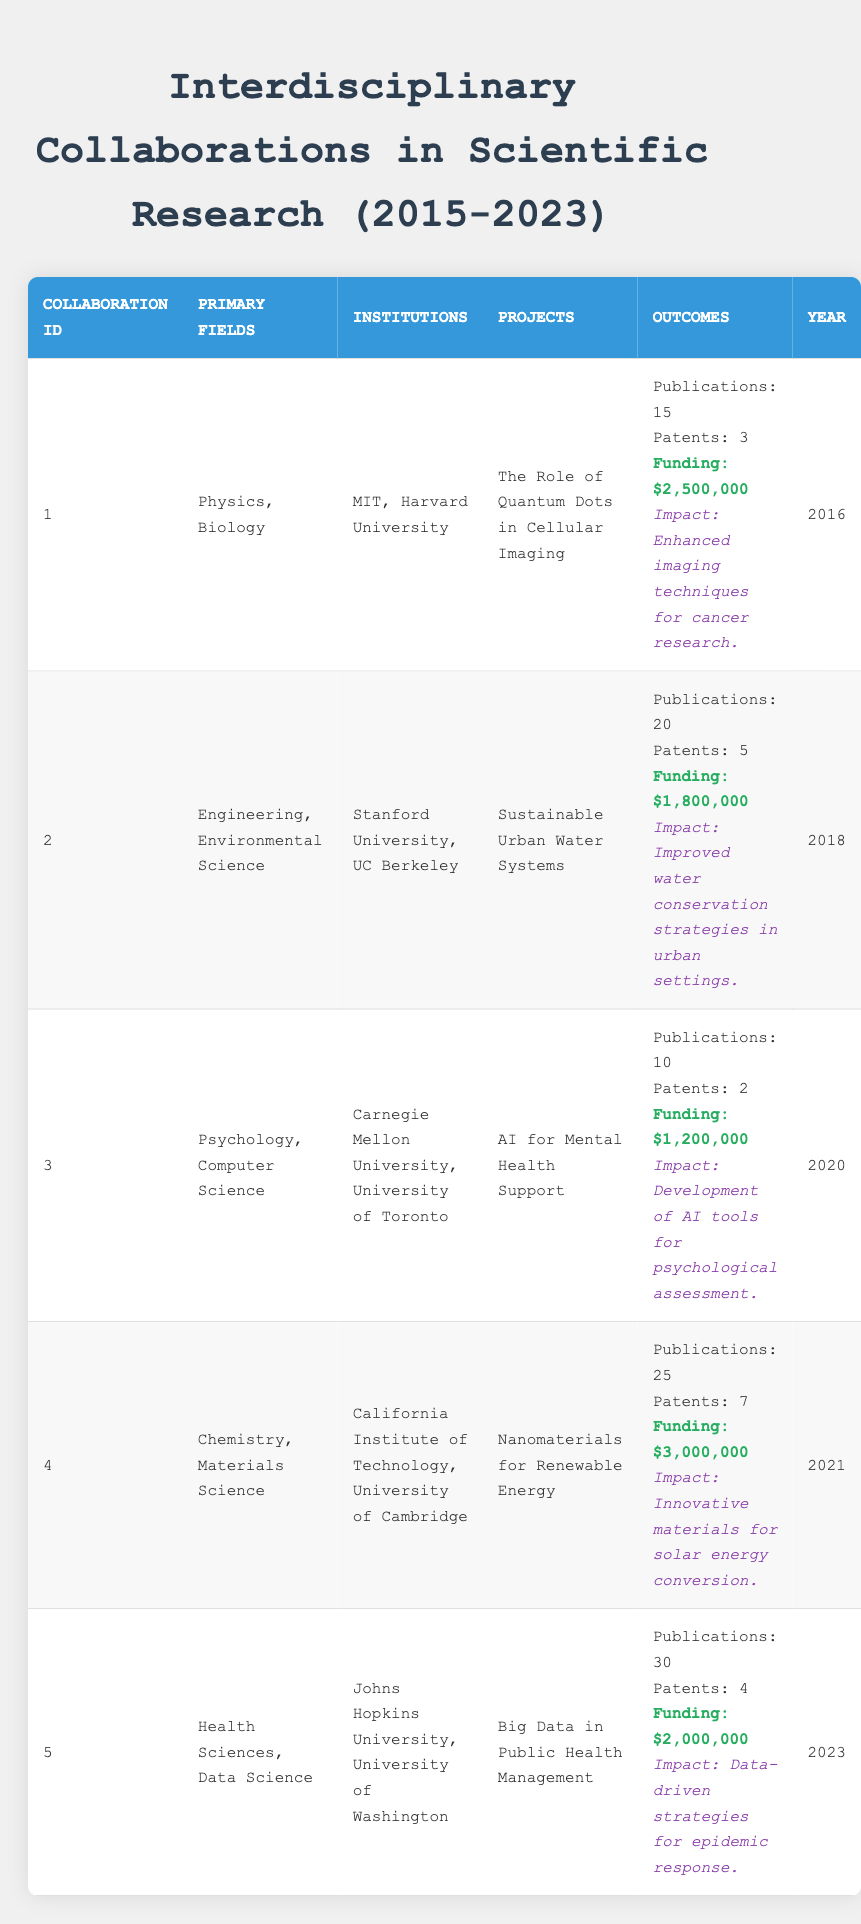What is the total funding amount for all collaborations listed? To find the total funding, I need to sum up the funding amounts from all collaborations. The funding amounts are: $2,500,000 (Collaboration 1), $1,800,000 (Collaboration 2), $1,200,000 (Collaboration 3), $3,000,000 (Collaboration 4), and $2,000,000 (Collaboration 5). Summing these gives $2,500,000 + $1,800,000 + $1,200,000 + $3,000,000 + $2,000,000 = $10,500,000.
Answer: $10,500,000 Which collaboration has the highest number of publications? Looking through the table, I compare the publications across all collaborations. The numbers are: 15, 20, 10, 25, and 30. The collaboration with the highest number is Collaboration 5 with 30 publications.
Answer: Collaboration 5 Did any collaboration result in more than 6 patents? I review the patents column and see the following data: 3 (Collaboration 1), 5 (Collaboration 2), 2 (Collaboration 3), 7 (Collaboration 4), and 4 (Collaboration 5). Collaboration 4 has 7 patents, which is more than 6, so the answer is yes.
Answer: Yes What is the average amount of funding per collaboration? To find the average funding, first sum the funding amounts, which is $10,500,000 as calculated earlier. There are 5 collaborations, so I divide the total funding by the number of collaborations: $10,500,000 divided by 5 equals $2,100,000.
Answer: $2,100,000 How many collaborations are focused on health-related sciences? I look at the primary fields of each collaboration. Only Collaboration 5 is specifically in health sciences, so there is one collaboration in this category.
Answer: 1 What is the difference in the number of patents between the collaboration with the most patents and the one with the fewest? I need to identify the maximum and minimum patents from the table: Collaboration 4 has 7 patents (maximum) and Collaboration 3 has 2 patents (minimum). The difference is 7 - 2 = 5.
Answer: 5 Is there any collaboration that combines engineering with health sciences? I check the primary fields for each collaboration. None of the collaborations include both engineering and health sciences, so the answer is no.
Answer: No 